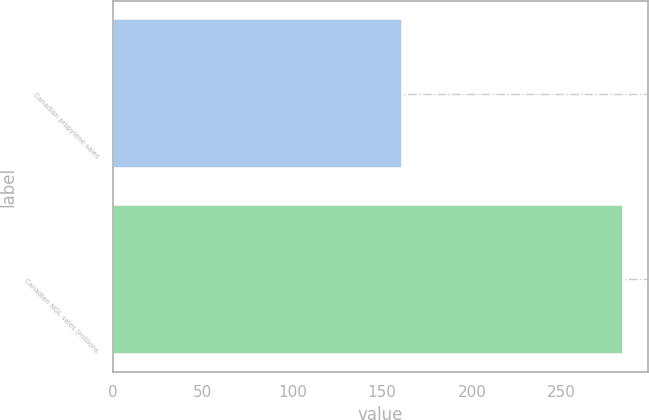Convert chart to OTSL. <chart><loc_0><loc_0><loc_500><loc_500><bar_chart><fcel>Canadian propylene sales<fcel>Canadian NGL sales (millions<nl><fcel>161<fcel>284<nl></chart> 